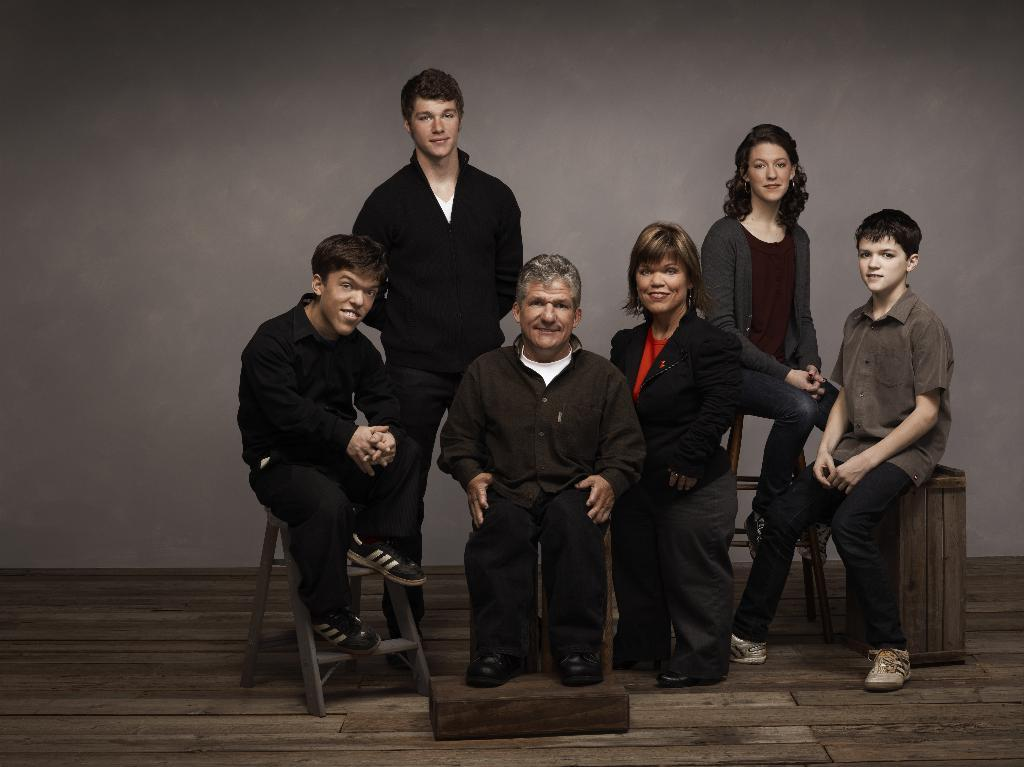How many people are in the image? There are persons in the image, but the exact number is not specified. What are the positions of the persons in the image? Some of the persons are sitting, and some are standing. What type of flooring is visible at the bottom of the image? There is a wooden floor at the bottom of the image. What can be seen in the background of the image? There is a wall in the background of the image. What type of feather can be seen floating in the air in the image? There is no feather present in the image, so it is not possible to determine if any feathers are floating in the air. 